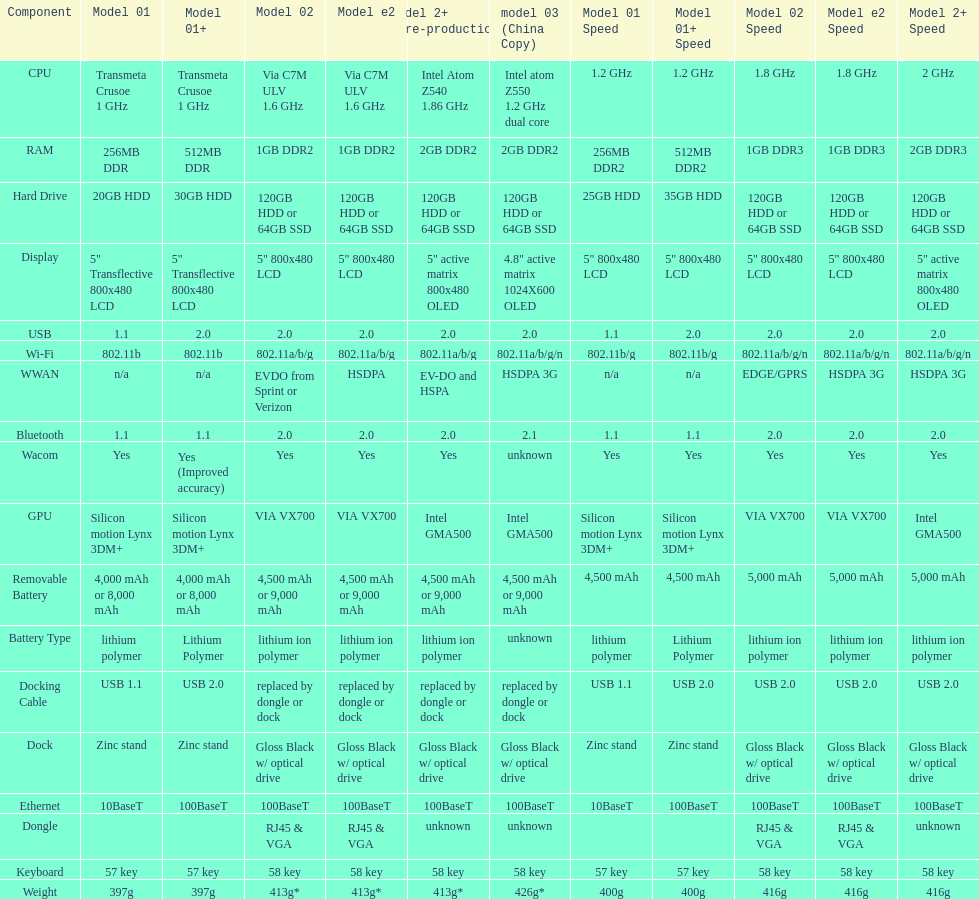How many models use a usb docking cable? 2. 